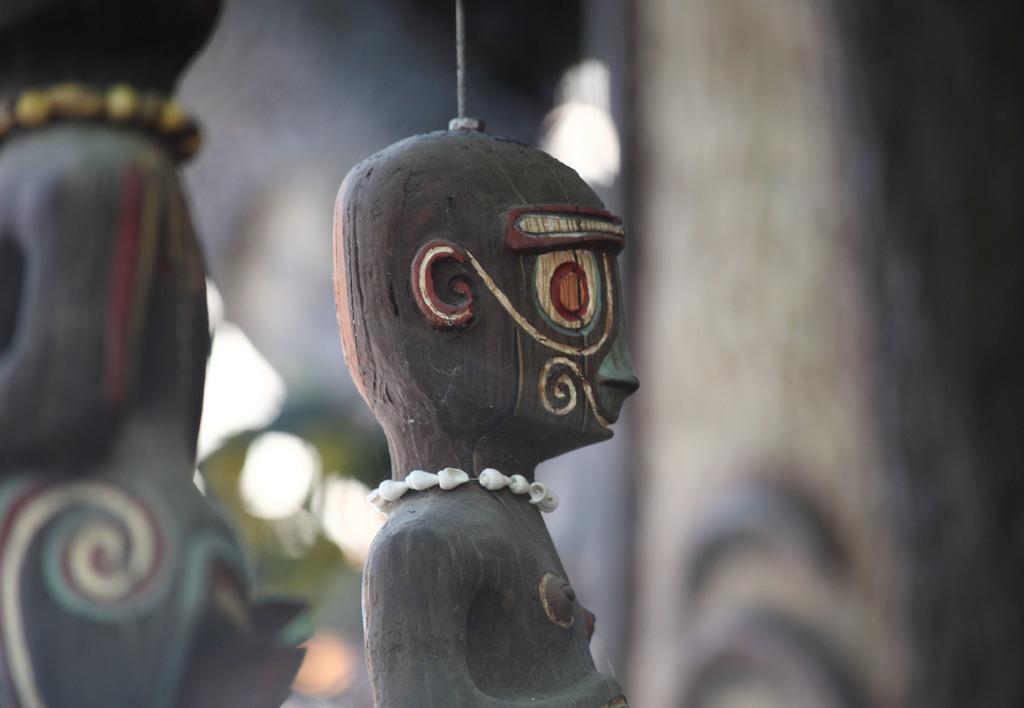Describe this image in one or two sentences. In this image I can see few toys and the toys are in brown and black color and I can see the blurred background. 